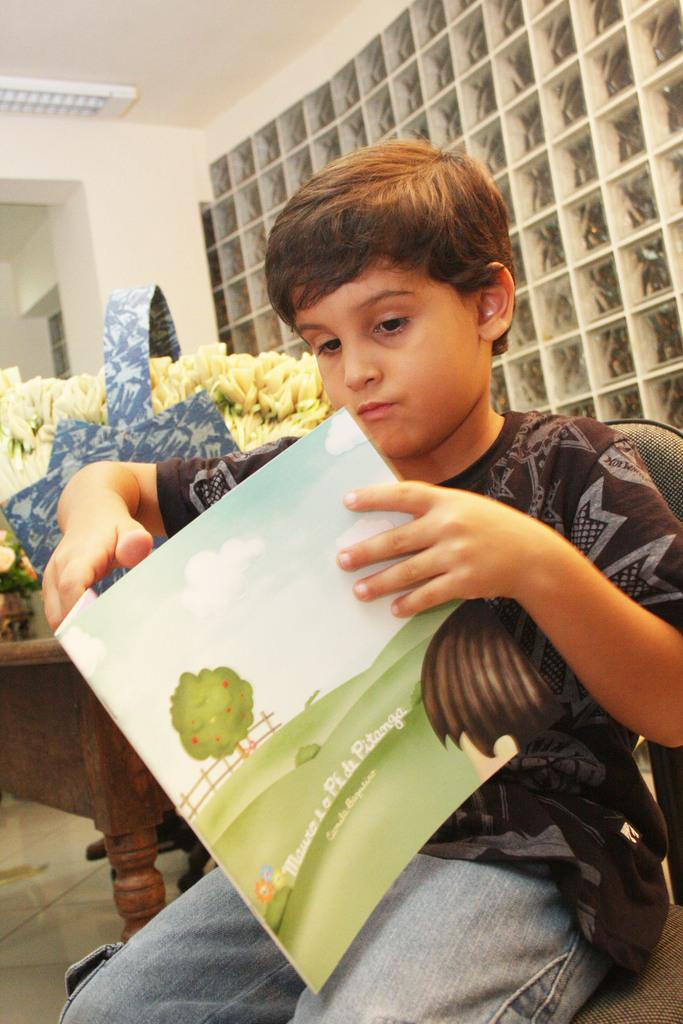Who is the main subject in the image? There is a boy in the image. What is the boy doing in the image? The boy is sitting on a chair and holding a book. What can be seen behind the boy? There is a wall behind the boy. What is visible at the top of the image? The top of the image includes a roof. What type of line can be seen connecting the boy to the wall in the image? There is no line connecting the boy to the wall in the image. How does the salt affect the boy's reading experience in the image? There is no salt present in the image, so it cannot affect the boy's reading experience. 